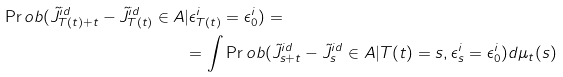Convert formula to latex. <formula><loc_0><loc_0><loc_500><loc_500>\Pr o b ( \tilde { J } _ { T ( t ) + t } ^ { i d } - \tilde { J } _ { T ( t ) } ^ { i d } \in A & | \epsilon _ { T ( t ) } ^ { i } = \epsilon _ { 0 } ^ { i } ) = \\ & = \int \Pr o b ( \tilde { J } _ { s + t } ^ { i d } - \tilde { J } _ { s } ^ { i d } \in A | T ( t ) = s , \epsilon _ { s } ^ { i } = \epsilon _ { 0 } ^ { i } ) d \mu _ { t } ( s )</formula> 